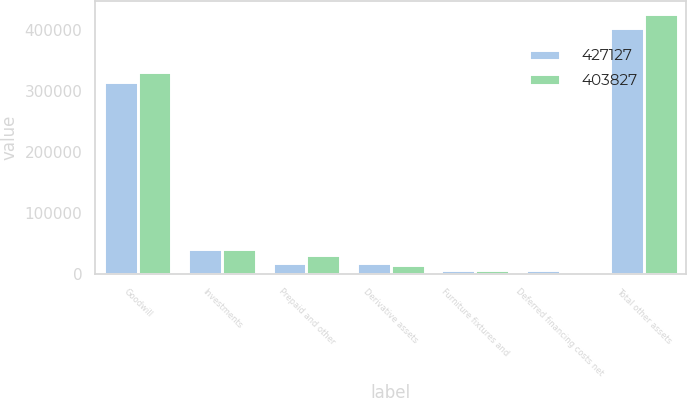Convert chart to OTSL. <chart><loc_0><loc_0><loc_500><loc_500><stacked_bar_chart><ecel><fcel>Goodwill<fcel>Investments<fcel>Prepaid and other<fcel>Derivative assets<fcel>Furniture fixtures and<fcel>Deferred financing costs net<fcel>Total other assets<nl><fcel>427127<fcel>314143<fcel>41287<fcel>17937<fcel>17482<fcel>6127<fcel>6851<fcel>403827<nl><fcel>403827<fcel>331884<fcel>41636<fcel>30332<fcel>14515<fcel>6123<fcel>2637<fcel>427127<nl></chart> 